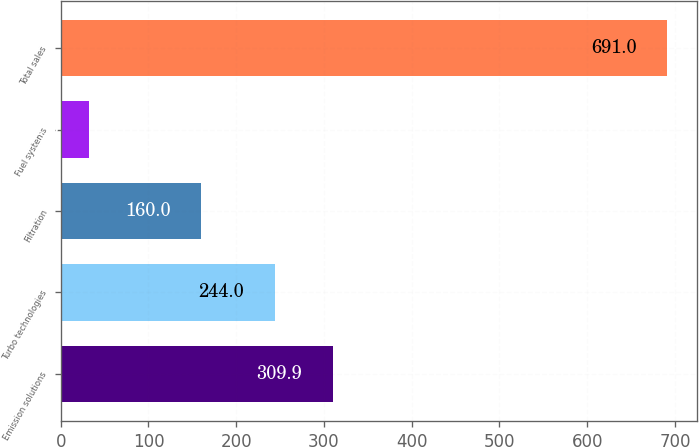Convert chart. <chart><loc_0><loc_0><loc_500><loc_500><bar_chart><fcel>Emission solutions<fcel>Turbo technologies<fcel>Filtration<fcel>Fuel systems<fcel>Total sales<nl><fcel>309.9<fcel>244<fcel>160<fcel>32<fcel>691<nl></chart> 